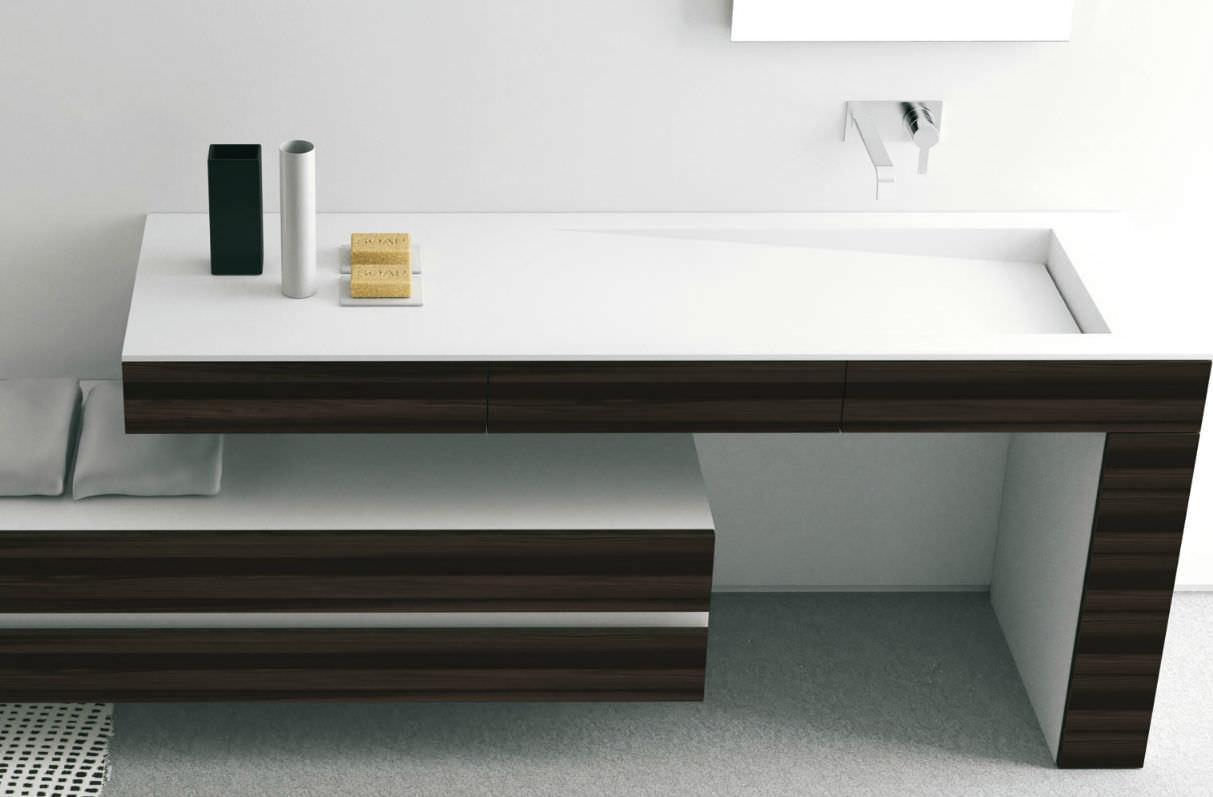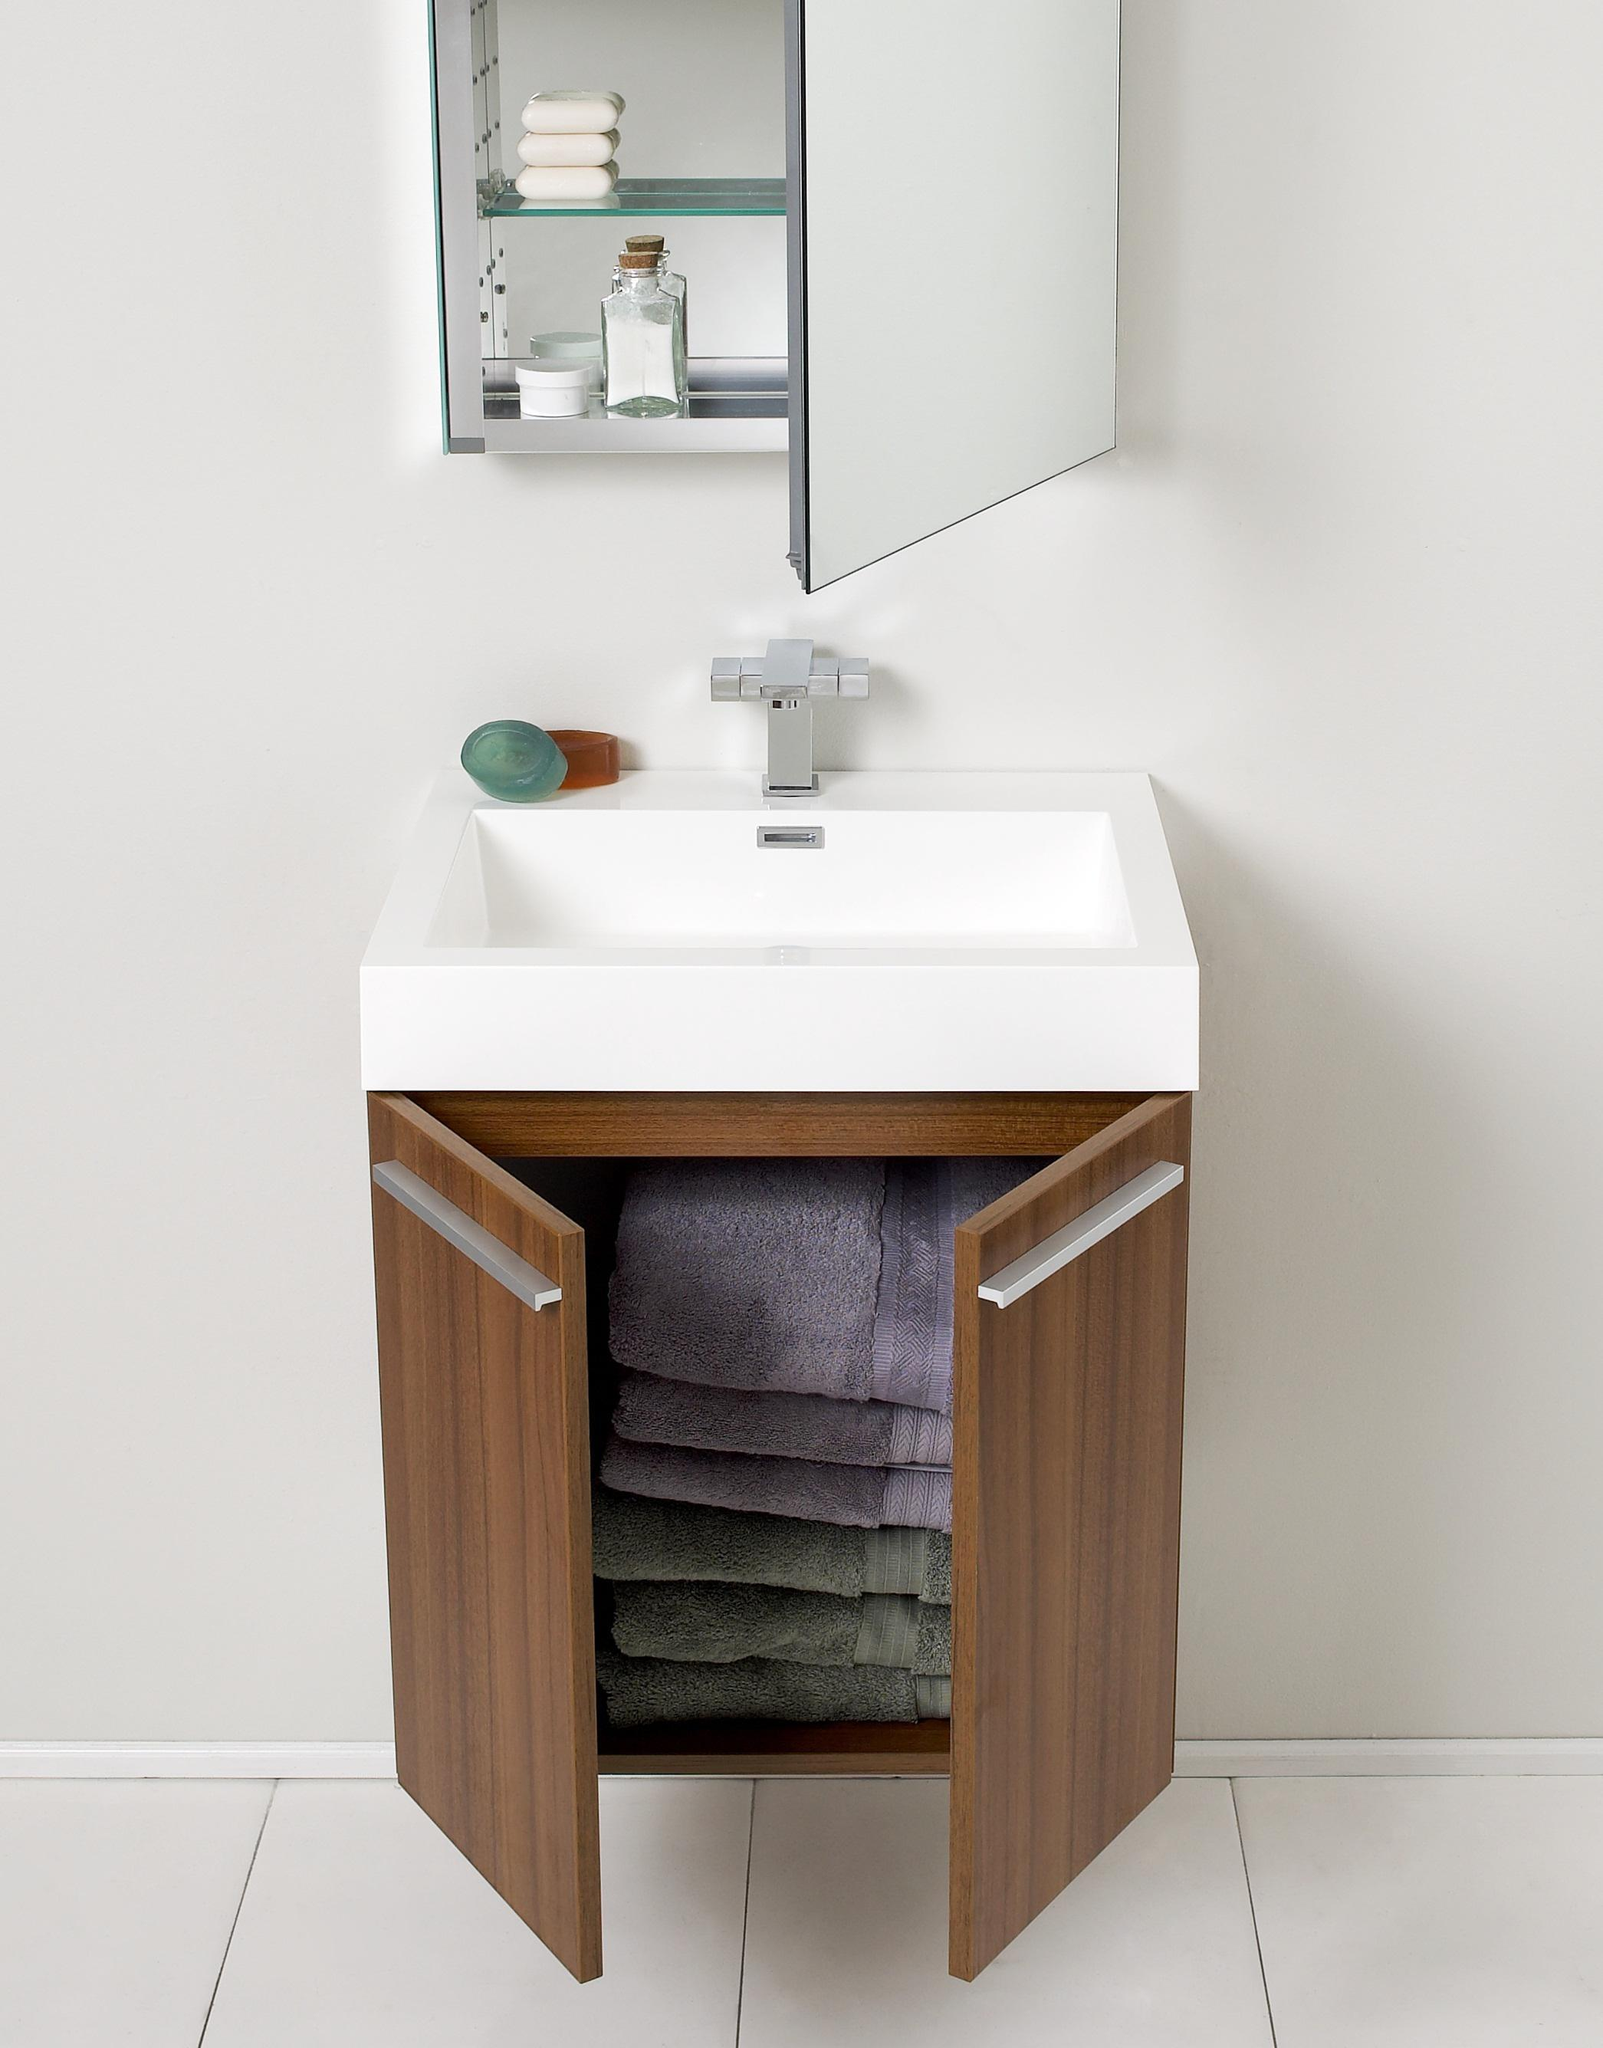The first image is the image on the left, the second image is the image on the right. Analyze the images presented: Is the assertion "One of images shows folded towels stored beneath the sink." valid? Answer yes or no. Yes. The first image is the image on the left, the second image is the image on the right. For the images displayed, is the sentence "One sink is round and the other is rectangular; also, one sink is inset, and the other is elevated above the counter." factually correct? Answer yes or no. No. 